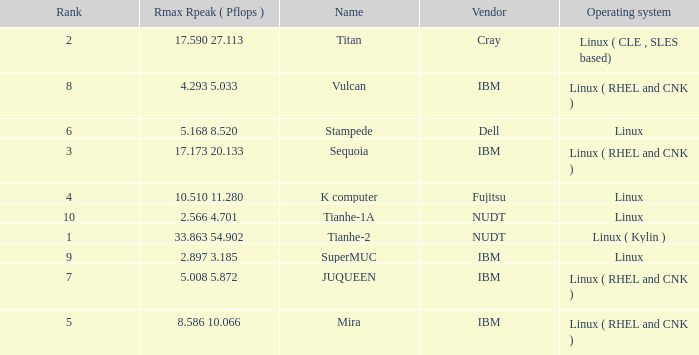What is the name of Rank 5? Mira. 